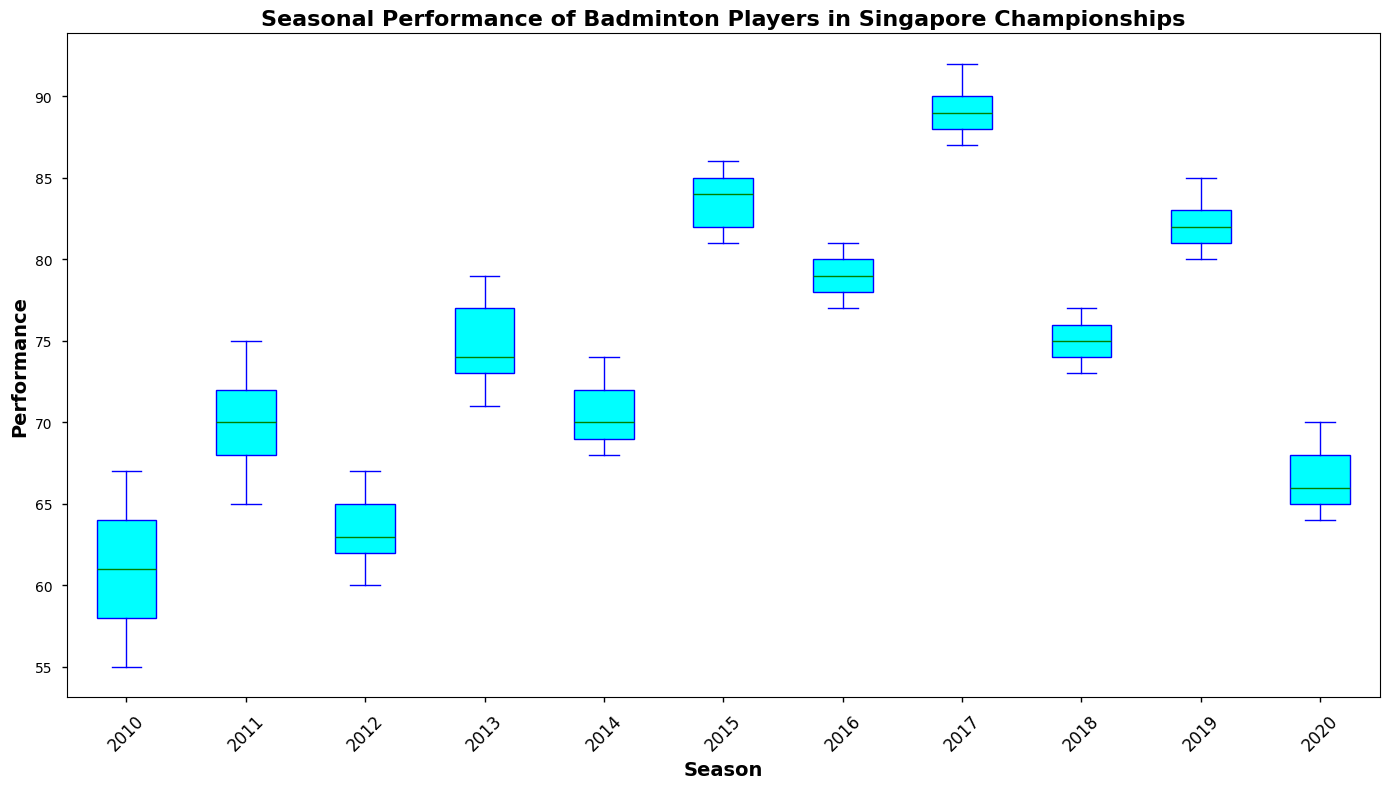What is the median Performance score in the 2012 season? To find the median score for the 2012 season, look at the middle line within the box for that season. The scores for 2012 are 62, 63, 65, 60, and 67. When sorted, these scores are 60, 62, 63, 65, and 67, so the median is 63.
Answer: 63 In which season did the badminton players have the highest median Performance? Compare the middle lines (medians) within each box across all seasons. The highest median appears to be in the 2017 season.
Answer: 2017 What's the interquartile range (IQR) for the 2015 season? The IQR is the difference between the third quartile (75th percentile) and the first quartile (25th percentile). For 2015, find the top and bottom edges of the box. The scores for 2015 are sorted as 81, 82, 84, 85, and 86, where the 25th percentile (Q1) is 82 and the 75th percentile (Q3) is 85. IQR = 85 - 82 = 3.
Answer: 3 How does the range of Performance scores in the 2014 season compare to the range in the 2016 season? The range is the difference between the maximum and minimum values. In 2014, the range is 74 - 68 = 6. In 2016, it's 81 - 77 = 4. Hence, the range in 2014 is greater than in 2016.
Answer: Greater in 2014 Describe the overall trend in the performance scores from 2010 to 2020. Observing the medians, performances generally increase from 2010 to a peak around 2017 and then decline by 2020.
Answer: Increase to 2017, then decline Which season shows the biggest difference between the upper and lower whiskers? Look at the lengths of the whiskers extending from each boxplot. The biggest distance appears in the 2019 season.
Answer: 2019 Were there any outliers in the 2020 season? Outliers are typically marked by small circles outside the whiskers. In 2020, there are no marked outliers.
Answer: No What color represents the box for each season, and what color represents the median line? Visually identify the color patterns. Each box is colored cyan, and the median line is green.
Answer: Cyan and green By how much did the median Performance score change from 2017 to 2018? Find the median for both years. The median for 2017 is 89, and for 2018, it is 74. The change is 89 - 74 = 15.
Answer: 15 What's the range of the maximum Performance scores from 2010 to 2020? The maximum scores for each season are the topmost points in the whiskers. They seem to span from approximately 64 (2010) to 92 (2017).
Answer: 64 to 92 